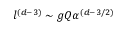Convert formula to latex. <formula><loc_0><loc_0><loc_500><loc_500>l ^ { ( d - 3 ) } \sim g Q \alpha ^ { ( d - 3 / 2 ) }</formula> 